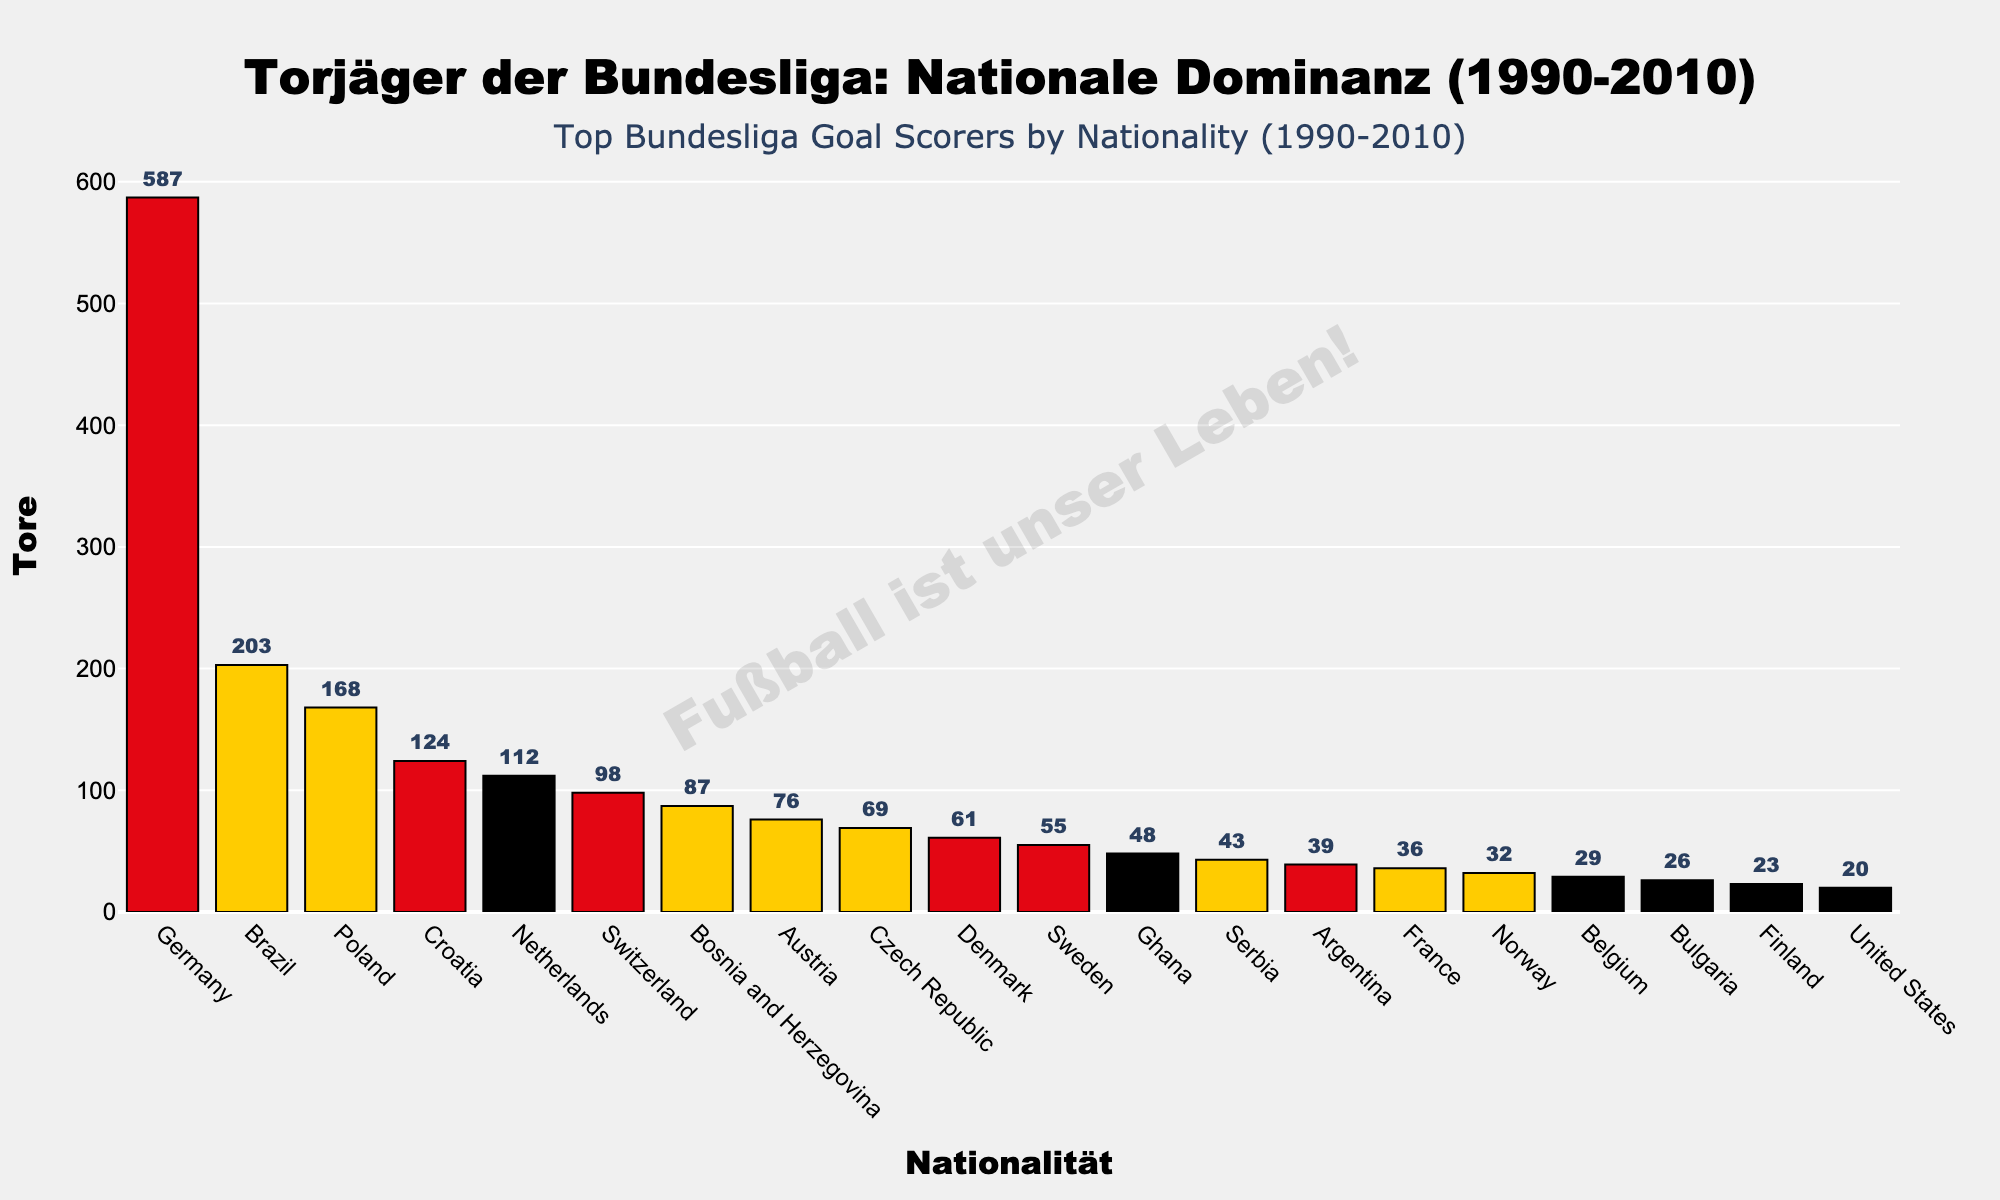Which nationality scored the highest number of goals? Looking at the bar chart, the tallest bar represents Germany, indicating that the highest number of goals was scored by German players.
Answer: Germany How many more goals did German players score than Brazilian players? To find the difference, subtract the goals scored by Brazilian players (203) from the goals scored by German players (587). So, 587 - 203 = 384.
Answer: 384 Which two nationalities scored more than 150 but less than 200 goals? Observe the bars between 150 and 200 goals on the chart. The nationalities that fall into this range are Poland (168) and Croatia (124 falls short), so only Poland fits the criteria, remove Croatia. None other fit for this range.
Answer: Poland How many nationalities scored fewer than 50 goals? Count the number of bars representing goals fewer than 50. These nationalities are Ghana (48), Serbia (43), Argentina (39), France (36), Norway (32), Belgium (29), Bulgaria (26), Finland (23), and the United States (20), totaling 9.
Answer: 9 Which nationality is the closest in goals to the Czech Republic? Check the values adjacent to the Czech Republic (69). Denmark (61) is closest with a difference of 8 goals.
Answer: Denmark What is the difference in goals scored by Netherlands and Sweden? Subtract the goals of Sweden (55) from the Netherlands (112). So, 112 - 55 = 57.
Answer: 57 How many goals were scored by players from countries starting with the letter "B"? Add the goals from Brazil (203), Bosnia and Herzegovina (87), Belgium (29), and Bulgaria (26). So, 203 + 87 + 29 + 26 = 345.
Answer: 345 What is the combined total goals scored by players from Scandinavian countries (Denmark, Sweden, Norway, Finland)? Add the goals from Denmark (61), Sweden (55), Norway (32), and Finland (23). So, 61 + 55 + 32 + 23 = 171.
Answer: 171 